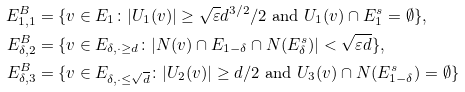Convert formula to latex. <formula><loc_0><loc_0><loc_500><loc_500>E _ { 1 , 1 } ^ { B } & = \{ v \in E _ { 1 } \colon | U _ { 1 } ( v ) | \geq \sqrt { \varepsilon } d ^ { 3 / 2 } / 2 \text { and } U _ { 1 } ( v ) \cap E _ { 1 } ^ { s } = \emptyset \} , \\ E _ { \delta , 2 } ^ { B } & = \{ v \in E _ { \delta , \cdot \geq d } \colon | N ( v ) \cap E _ { 1 - \delta } \cap N ( E _ { \delta } ^ { s } ) | < \sqrt { \varepsilon d } \} , \\ E _ { \delta , 3 } ^ { B } & = \{ v \in E _ { \delta , \cdot \leq \sqrt { d } } \colon | U _ { 2 } ( v ) | \geq d / 2 \text { and } U _ { 3 } ( v ) \cap N ( E _ { 1 - \delta } ^ { s } ) = \emptyset \}</formula> 